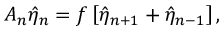<formula> <loc_0><loc_0><loc_500><loc_500>A _ { n } \hat { \eta } _ { n } = f \left [ \hat { \eta } _ { n + 1 } + \hat { \eta } _ { n - 1 } \right ] ,</formula> 